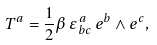<formula> <loc_0><loc_0><loc_500><loc_500>T ^ { a } = \frac { 1 } { 2 } \beta \, \varepsilon _ { \, b c } ^ { \, a } \, e ^ { b } \wedge e ^ { c } ,</formula> 